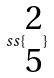<formula> <loc_0><loc_0><loc_500><loc_500>s s \{ \begin{matrix} 2 \\ 5 \end{matrix} \}</formula> 